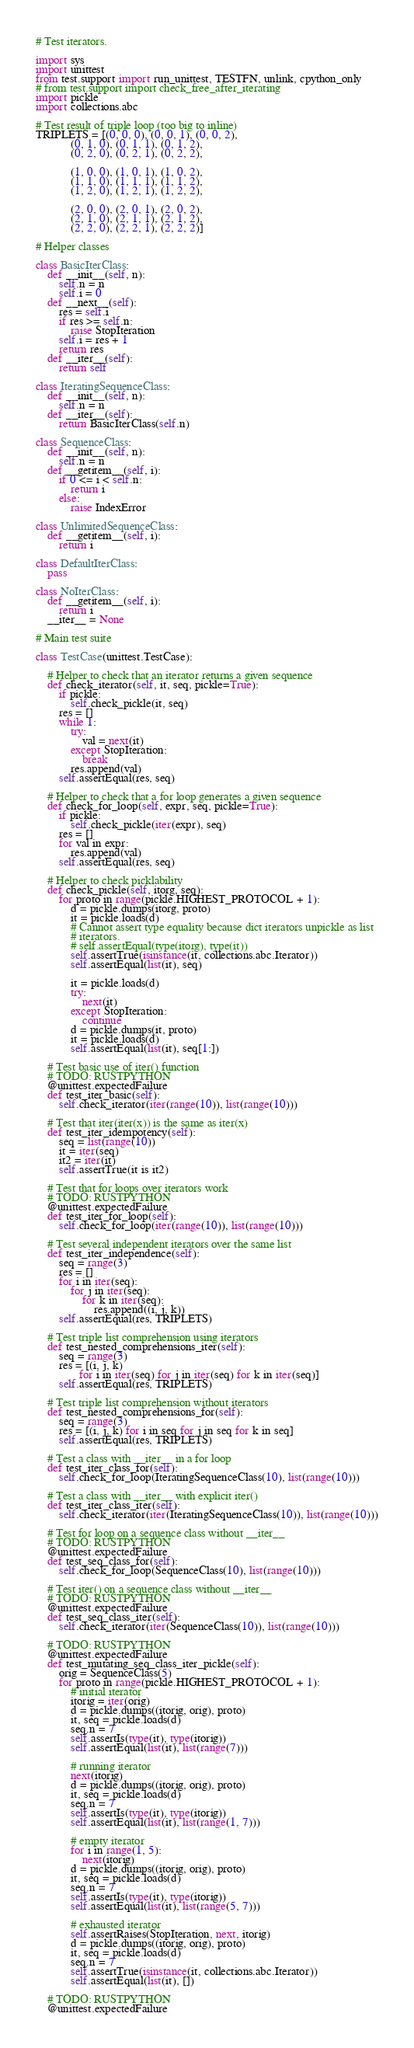Convert code to text. <code><loc_0><loc_0><loc_500><loc_500><_Python_># Test iterators.

import sys
import unittest
from test.support import run_unittest, TESTFN, unlink, cpython_only
# from test.support import check_free_after_iterating
import pickle
import collections.abc

# Test result of triple loop (too big to inline)
TRIPLETS = [(0, 0, 0), (0, 0, 1), (0, 0, 2),
            (0, 1, 0), (0, 1, 1), (0, 1, 2),
            (0, 2, 0), (0, 2, 1), (0, 2, 2),

            (1, 0, 0), (1, 0, 1), (1, 0, 2),
            (1, 1, 0), (1, 1, 1), (1, 1, 2),
            (1, 2, 0), (1, 2, 1), (1, 2, 2),

            (2, 0, 0), (2, 0, 1), (2, 0, 2),
            (2, 1, 0), (2, 1, 1), (2, 1, 2),
            (2, 2, 0), (2, 2, 1), (2, 2, 2)]

# Helper classes

class BasicIterClass:
    def __init__(self, n):
        self.n = n
        self.i = 0
    def __next__(self):
        res = self.i
        if res >= self.n:
            raise StopIteration
        self.i = res + 1
        return res
    def __iter__(self):
        return self

class IteratingSequenceClass:
    def __init__(self, n):
        self.n = n
    def __iter__(self):
        return BasicIterClass(self.n)

class SequenceClass:
    def __init__(self, n):
        self.n = n
    def __getitem__(self, i):
        if 0 <= i < self.n:
            return i
        else:
            raise IndexError

class UnlimitedSequenceClass:
    def __getitem__(self, i):
        return i

class DefaultIterClass:
    pass

class NoIterClass:
    def __getitem__(self, i):
        return i
    __iter__ = None

# Main test suite

class TestCase(unittest.TestCase):

    # Helper to check that an iterator returns a given sequence
    def check_iterator(self, it, seq, pickle=True):
        if pickle:
            self.check_pickle(it, seq)
        res = []
        while 1:
            try:
                val = next(it)
            except StopIteration:
                break
            res.append(val)
        self.assertEqual(res, seq)

    # Helper to check that a for loop generates a given sequence
    def check_for_loop(self, expr, seq, pickle=True):
        if pickle:
            self.check_pickle(iter(expr), seq)
        res = []
        for val in expr:
            res.append(val)
        self.assertEqual(res, seq)

    # Helper to check picklability
    def check_pickle(self, itorg, seq):
        for proto in range(pickle.HIGHEST_PROTOCOL + 1):
            d = pickle.dumps(itorg, proto)
            it = pickle.loads(d)
            # Cannot assert type equality because dict iterators unpickle as list
            # iterators.
            # self.assertEqual(type(itorg), type(it))
            self.assertTrue(isinstance(it, collections.abc.Iterator))
            self.assertEqual(list(it), seq)

            it = pickle.loads(d)
            try:
                next(it)
            except StopIteration:
                continue
            d = pickle.dumps(it, proto)
            it = pickle.loads(d)
            self.assertEqual(list(it), seq[1:])

    # Test basic use of iter() function
    # TODO: RUSTPYTHON
    @unittest.expectedFailure
    def test_iter_basic(self):
        self.check_iterator(iter(range(10)), list(range(10)))

    # Test that iter(iter(x)) is the same as iter(x)
    def test_iter_idempotency(self):
        seq = list(range(10))
        it = iter(seq)
        it2 = iter(it)
        self.assertTrue(it is it2)

    # Test that for loops over iterators work
    # TODO: RUSTPYTHON
    @unittest.expectedFailure
    def test_iter_for_loop(self):
        self.check_for_loop(iter(range(10)), list(range(10)))

    # Test several independent iterators over the same list
    def test_iter_independence(self):
        seq = range(3)
        res = []
        for i in iter(seq):
            for j in iter(seq):
                for k in iter(seq):
                    res.append((i, j, k))
        self.assertEqual(res, TRIPLETS)

    # Test triple list comprehension using iterators
    def test_nested_comprehensions_iter(self):
        seq = range(3)
        res = [(i, j, k)
               for i in iter(seq) for j in iter(seq) for k in iter(seq)]
        self.assertEqual(res, TRIPLETS)

    # Test triple list comprehension without iterators
    def test_nested_comprehensions_for(self):
        seq = range(3)
        res = [(i, j, k) for i in seq for j in seq for k in seq]
        self.assertEqual(res, TRIPLETS)

    # Test a class with __iter__ in a for loop
    def test_iter_class_for(self):
        self.check_for_loop(IteratingSequenceClass(10), list(range(10)))

    # Test a class with __iter__ with explicit iter()
    def test_iter_class_iter(self):
        self.check_iterator(iter(IteratingSequenceClass(10)), list(range(10)))

    # Test for loop on a sequence class without __iter__
    # TODO: RUSTPYTHON
    @unittest.expectedFailure
    def test_seq_class_for(self):
        self.check_for_loop(SequenceClass(10), list(range(10)))

    # Test iter() on a sequence class without __iter__
    # TODO: RUSTPYTHON
    @unittest.expectedFailure
    def test_seq_class_iter(self):
        self.check_iterator(iter(SequenceClass(10)), list(range(10)))

    # TODO: RUSTPYTHON
    @unittest.expectedFailure
    def test_mutating_seq_class_iter_pickle(self):
        orig = SequenceClass(5)
        for proto in range(pickle.HIGHEST_PROTOCOL + 1):
            # initial iterator
            itorig = iter(orig)
            d = pickle.dumps((itorig, orig), proto)
            it, seq = pickle.loads(d)
            seq.n = 7
            self.assertIs(type(it), type(itorig))
            self.assertEqual(list(it), list(range(7)))

            # running iterator
            next(itorig)
            d = pickle.dumps((itorig, orig), proto)
            it, seq = pickle.loads(d)
            seq.n = 7
            self.assertIs(type(it), type(itorig))
            self.assertEqual(list(it), list(range(1, 7)))

            # empty iterator
            for i in range(1, 5):
                next(itorig)
            d = pickle.dumps((itorig, orig), proto)
            it, seq = pickle.loads(d)
            seq.n = 7
            self.assertIs(type(it), type(itorig))
            self.assertEqual(list(it), list(range(5, 7)))

            # exhausted iterator
            self.assertRaises(StopIteration, next, itorig)
            d = pickle.dumps((itorig, orig), proto)
            it, seq = pickle.loads(d)
            seq.n = 7
            self.assertTrue(isinstance(it, collections.abc.Iterator))
            self.assertEqual(list(it), [])

    # TODO: RUSTPYTHON
    @unittest.expectedFailure</code> 